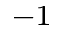<formula> <loc_0><loc_0><loc_500><loc_500>^ { - 1 }</formula> 